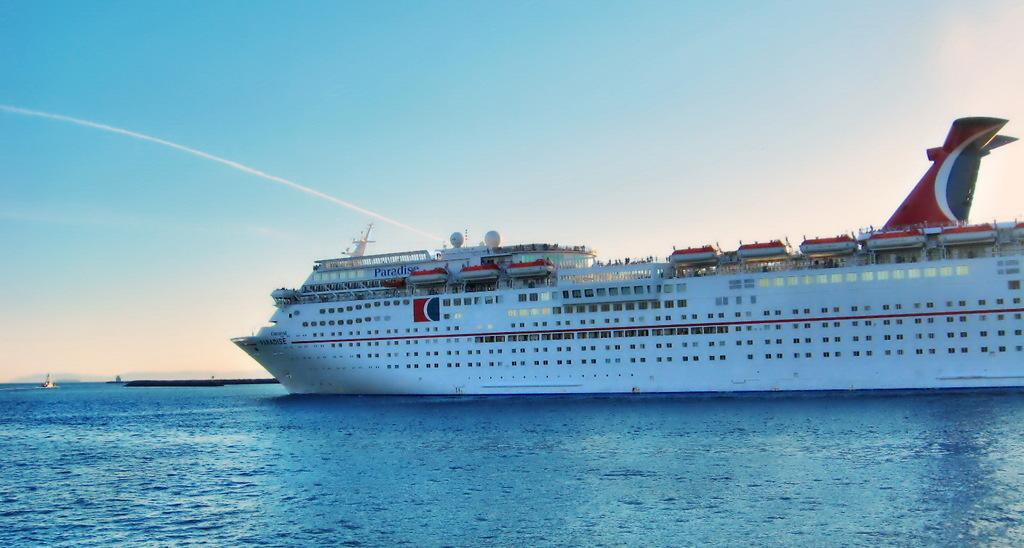Provide a one-sentence caption for the provided image. A large cruise ship with the word Paradise written on the side of it sails in the ocean. 